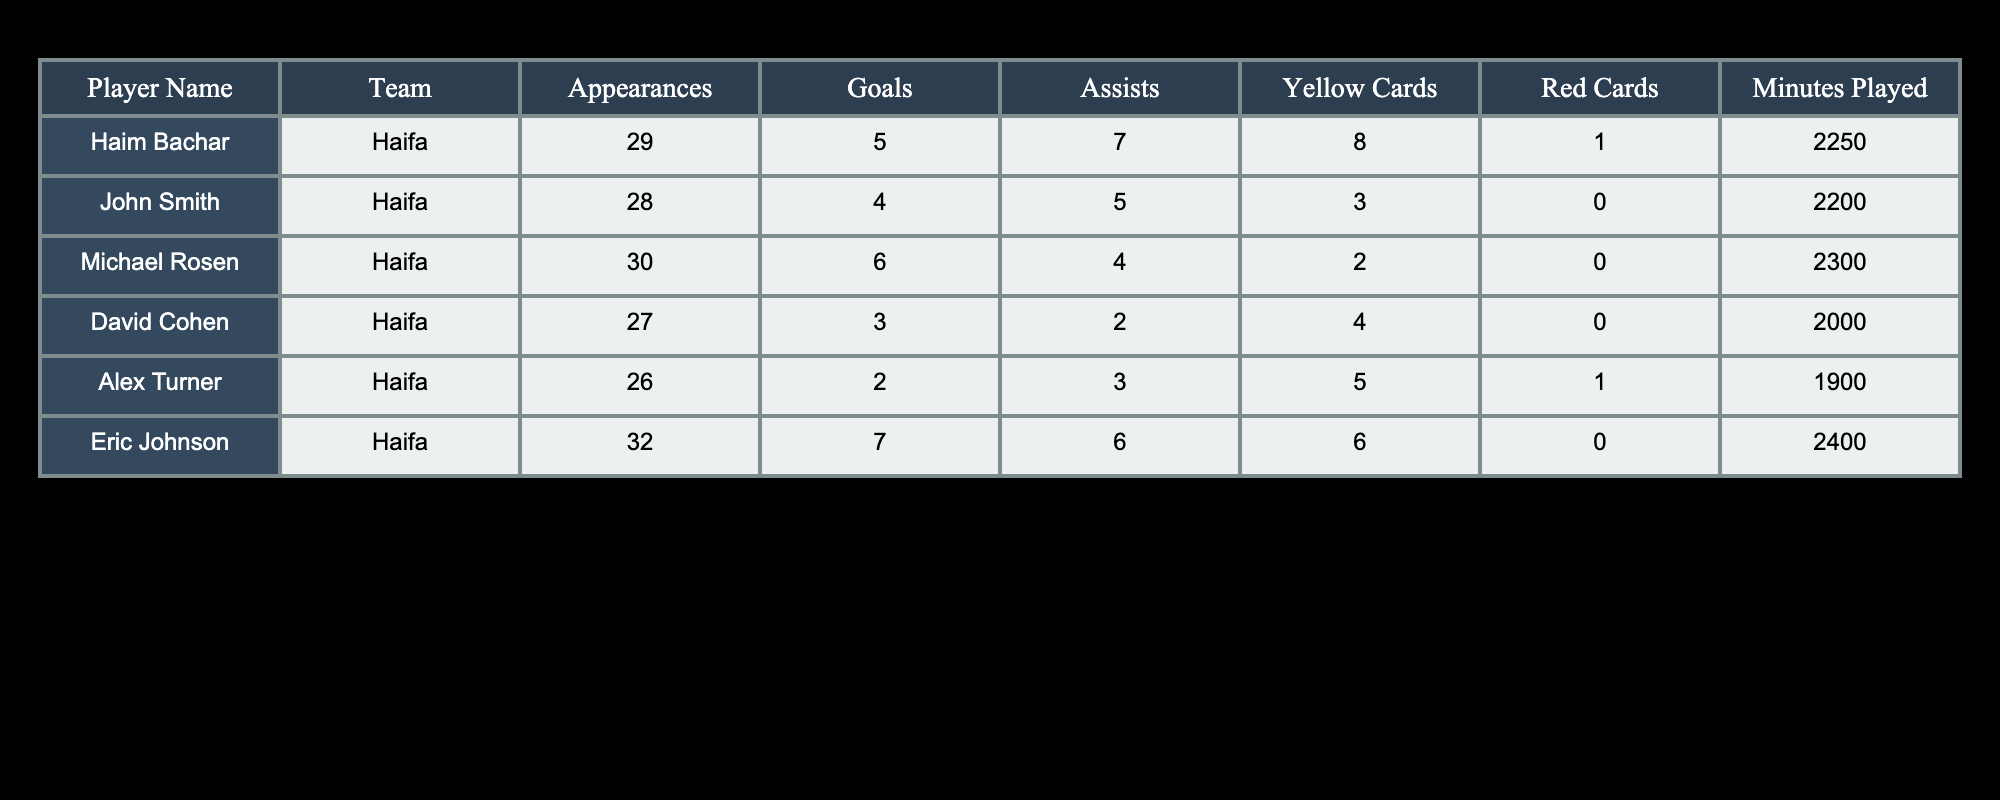What was the total number of goals scored by all players? Add the goals from each player: Haim Bachar (5), John Smith (4), Michael Rosen (6), David Cohen (3), Alex Turner (2), and Eric Johnson (7). So, 5 + 4 + 6 + 3 + 2 + 7 = 27.
Answer: 27 Who had the highest number of assists? Compare the assists for each player: Haim Bachar (7), John Smith (5), Michael Rosen (4), David Cohen (2), Alex Turner (3), and Eric Johnson (6). Haim Bachar has the most assists with 7.
Answer: Haim Bachar How many players received yellow cards in total? Total the yellow cards for each player: Haim Bachar (8), John Smith (3), Michael Rosen (2), David Cohen (4), Alex Turner (5), and Eric Johnson (6). Thus, 8 + 3 + 2 + 4 + 5 + 6 = 28 yellow cards.
Answer: 28 Is it true that Michael Rosen played more minutes than Alex Turner? Check the minutes played: Michael Rosen (2300 minutes) and Alex Turner (1900 minutes). Since 2300 is greater than 1900, the statement is true.
Answer: Yes Which team had the player with the most red cards? Look at the red cards for each player: Haim Bachar (1), John Smith (0), Michael Rosen (0), David Cohen (0), Alex Turner (1), and Eric Johnson (0). Haim Bachar and Alex Turner both have the highest red cards, which is 1.
Answer: Haifa 